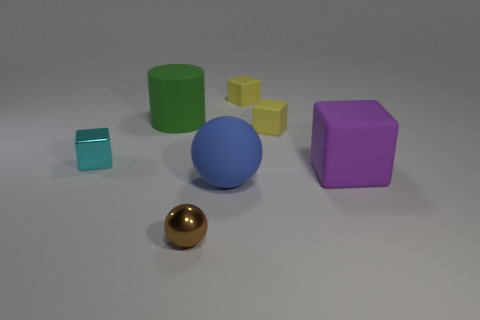Can you comment on the colors seen in the scene? The scene displays a range of colors. The dominant colors are the matte blue of the large ball, the shiny gold of the small ball, the vivid purple of the cube, the bright green of the cylinder, the yellow hues of the smaller cubes, and the light cyan of the transparent cube. The diversity of colors adds vibrancy to the image, contrasting nicely against the neutral gray background. 